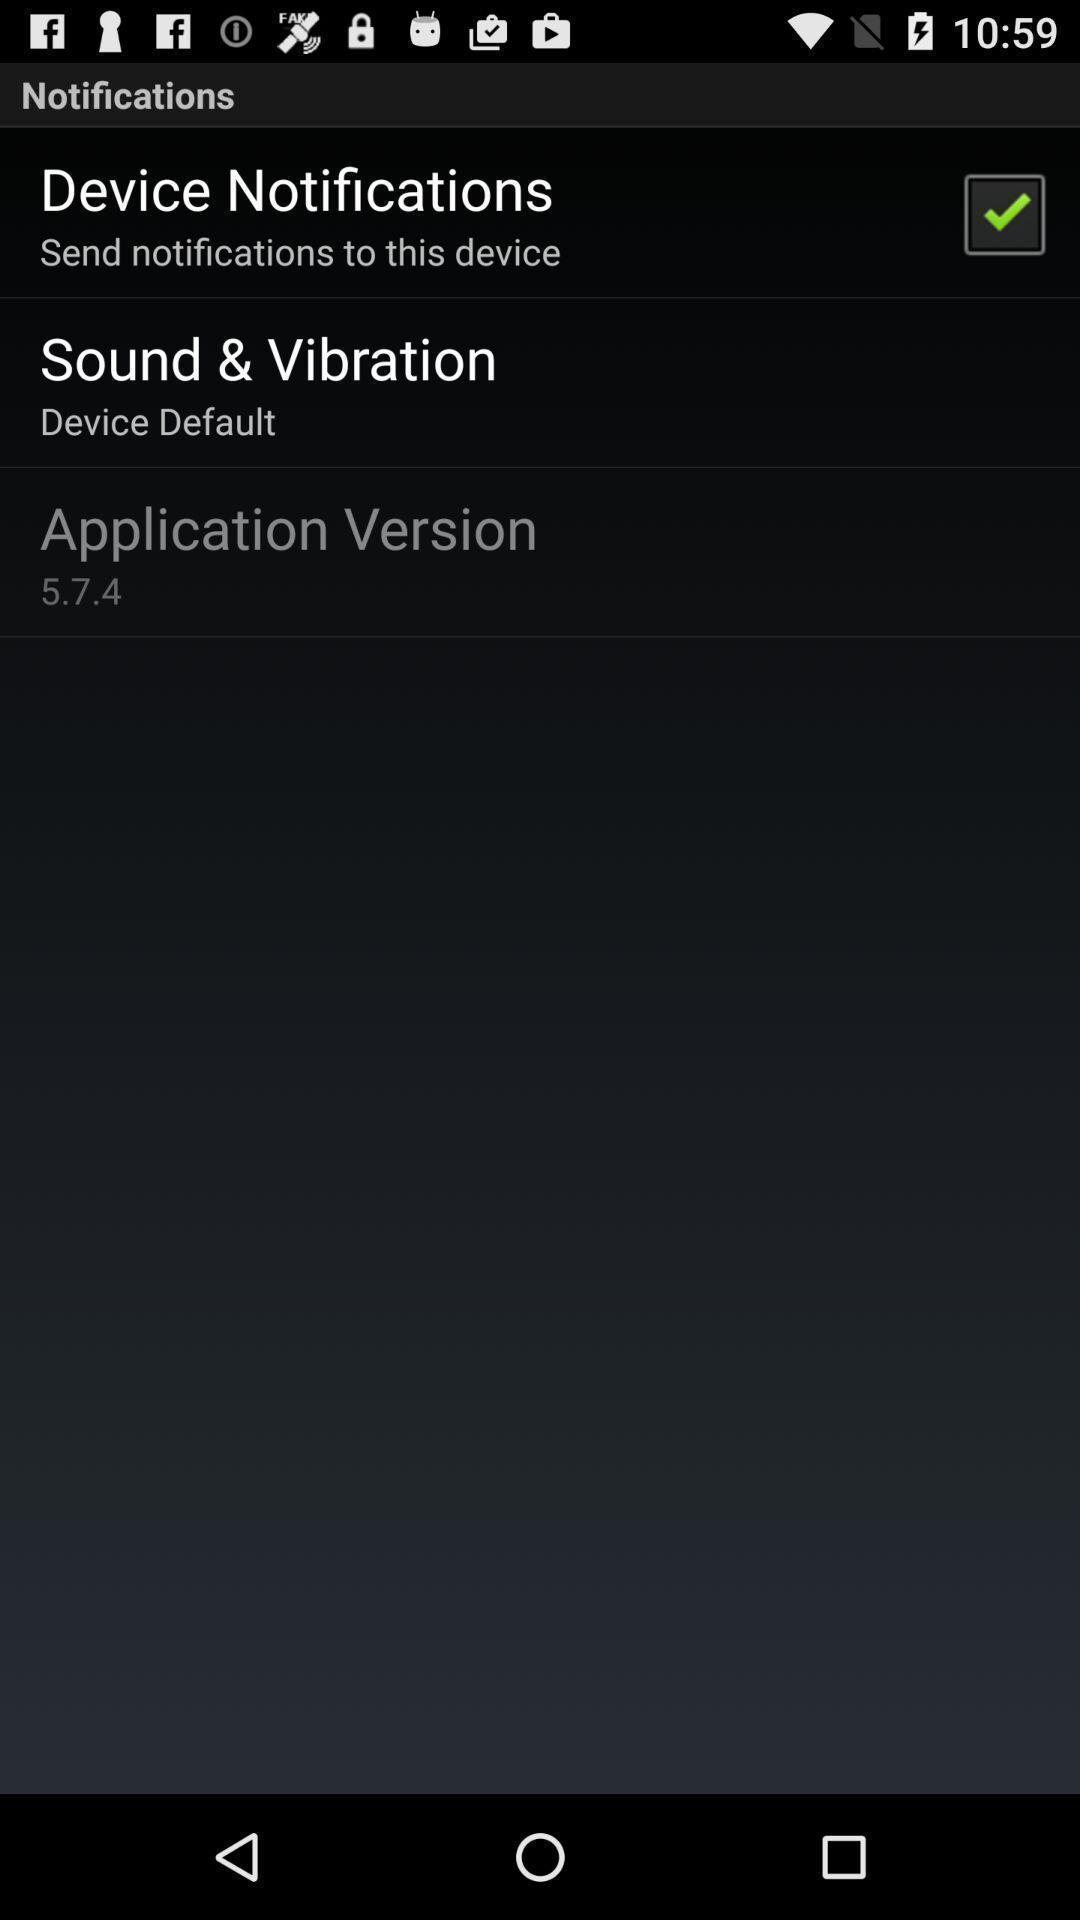Provide a textual representation of this image. Showing notifications page. 